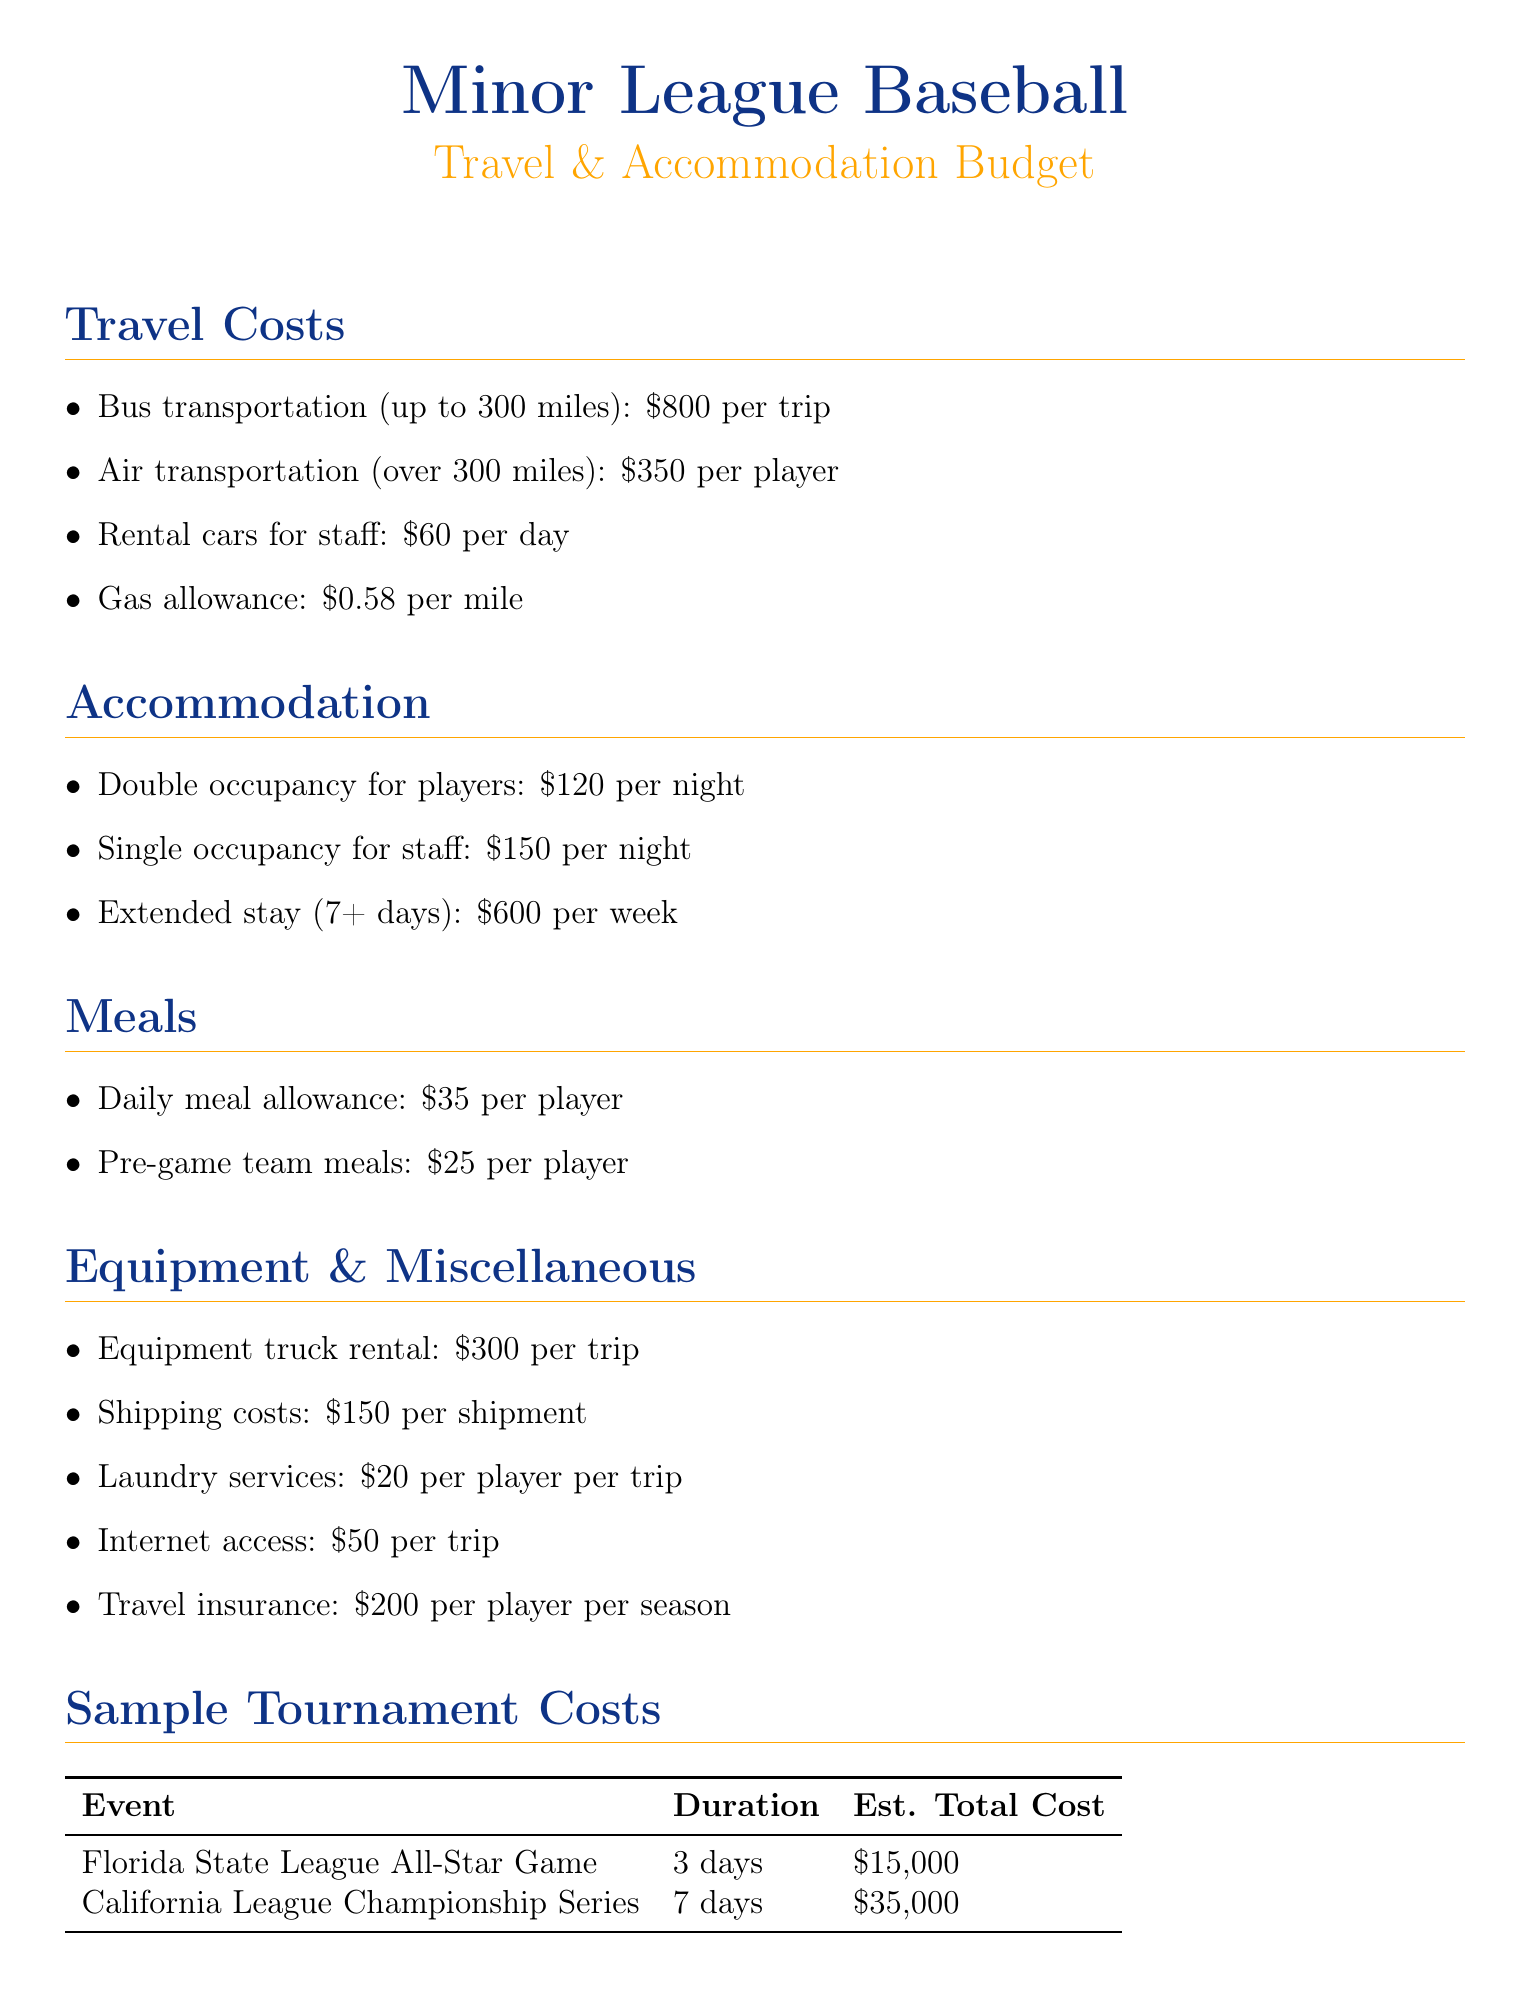What is the estimated cost per trip for bus transportation? The estimated cost for bus transportation is listed directly in the document, which is $800 per trip.
Answer: $800 What type of meals has a per diem allowance? The document specifies that there is a daily meal allowance issued as per diem for players, costing $35 per day.
Answer: $35 What is the duration of the California League Championship Series? This information can be found in the sample tournament costs section, which indicates that the duration of this event is 7 days.
Answer: 7 days How much does laundry services cost per player per trip? The document provides an estimate for laundry services, which is $20 per player per trip.
Answer: $20 What is the estimated total cost for the Florida State League All-Star Game? This information can be found in the sample tournament costs section, which lists the estimated total cost as $15,000.
Answer: $15,000 What is the cost per week for extended stay apartments? The document states that the estimated cost for extended stay apartments is $600 per week.
Answer: $600 What is the estimated cost of travel insurance per player per season? According to the miscellaneous expenses section, the travel insurance is estimated to cost $200 per player per season.
Answer: $200 What is included in the description for air transportation? The document specifically notes that air transportation is for commercial flights for long-distance trips, which are over 300 miles.
Answer: Commercial flights for long-distance trips What is the estimated total cost for the away series against the Bowling Green Hot Rods? In the sample away series costs section, the estimated total cost for this series is mentioned as $12,000.
Answer: $12,000 What transportation method is used for long-distance trips over 300 miles? The document indicates that air transportation, specifically commercial flights, is the method used for these trips.
Answer: Air transportation 